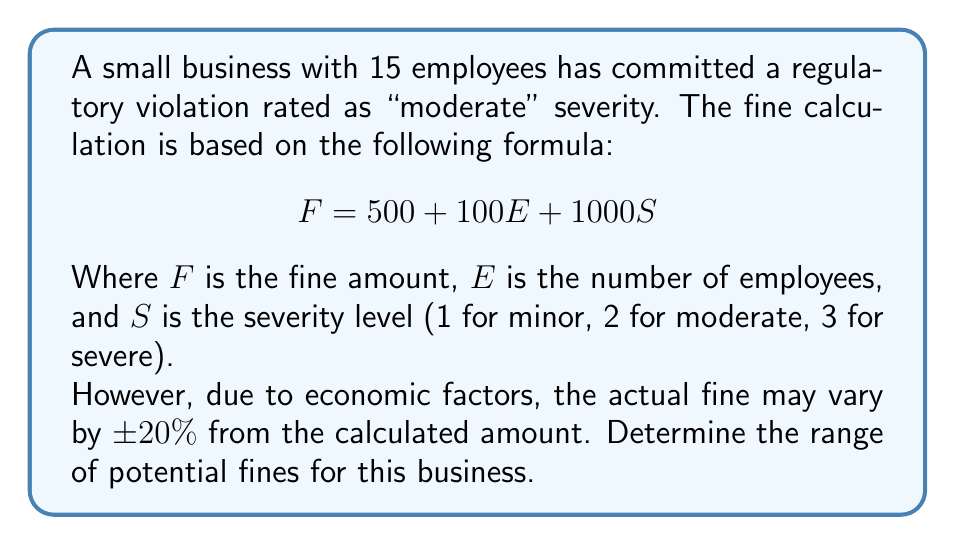Provide a solution to this math problem. 1. Calculate the base fine amount:
   $$F = 500 + 100E + 1000S$$
   $$F = 500 + 100(15) + 1000(2)$$
   $$F = 500 + 1500 + 2000 = 4000$$

2. Calculate the potential variation (20% of the base fine):
   $$\text{Variation} = 20\% \times 4000 = 0.2 \times 4000 = 800$$

3. Determine the lower bound of the fine range:
   $$\text{Lower bound} = 4000 - 800 = 3200$$

4. Determine the upper bound of the fine range:
   $$\text{Upper bound} = 4000 + 800 = 4800$$

5. Express the range using inequality notation:
   $$3200 \leq F \leq 4800$$
Answer: $3200 \leq F \leq 4800$ 